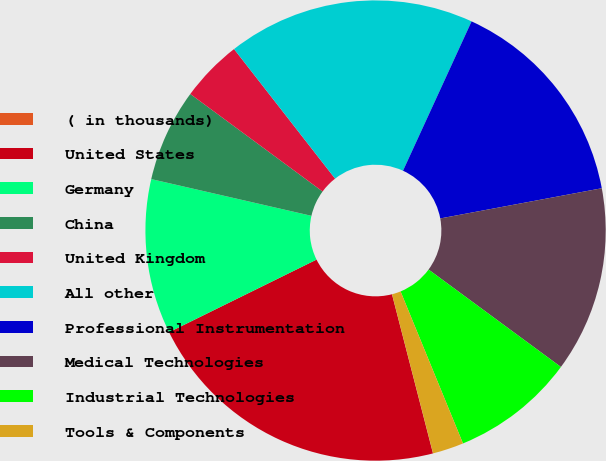Convert chart to OTSL. <chart><loc_0><loc_0><loc_500><loc_500><pie_chart><fcel>( in thousands)<fcel>United States<fcel>Germany<fcel>China<fcel>United Kingdom<fcel>All other<fcel>Professional Instrumentation<fcel>Medical Technologies<fcel>Industrial Technologies<fcel>Tools & Components<nl><fcel>0.01%<fcel>21.73%<fcel>10.87%<fcel>6.52%<fcel>4.35%<fcel>17.39%<fcel>15.21%<fcel>13.04%<fcel>8.7%<fcel>2.18%<nl></chart> 